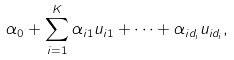<formula> <loc_0><loc_0><loc_500><loc_500>\alpha _ { 0 } + \sum _ { i = 1 } ^ { K } \alpha _ { i 1 } u _ { i 1 } + \dots + \alpha _ { i d _ { i } } u _ { i d _ { i } } ,</formula> 